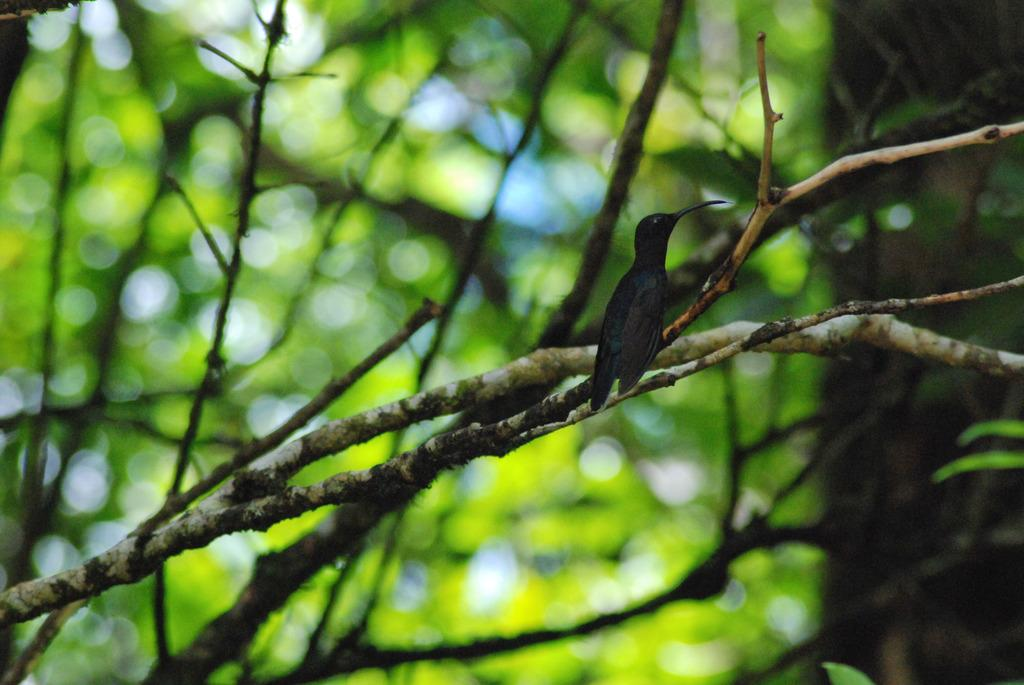What type of animal can be seen in the image? There is a bird in the image. Where is the bird located? The bird is on a branch of a tree. What can be seen in the background of the image? There are trees visible in the background of the image. What type of town can be seen in the image? There is no town present in the image; it features a bird on a tree branch. What is the bird using to dig in the image? There is no rake or digging activity present in the image; the bird is simply perched on a tree branch. 